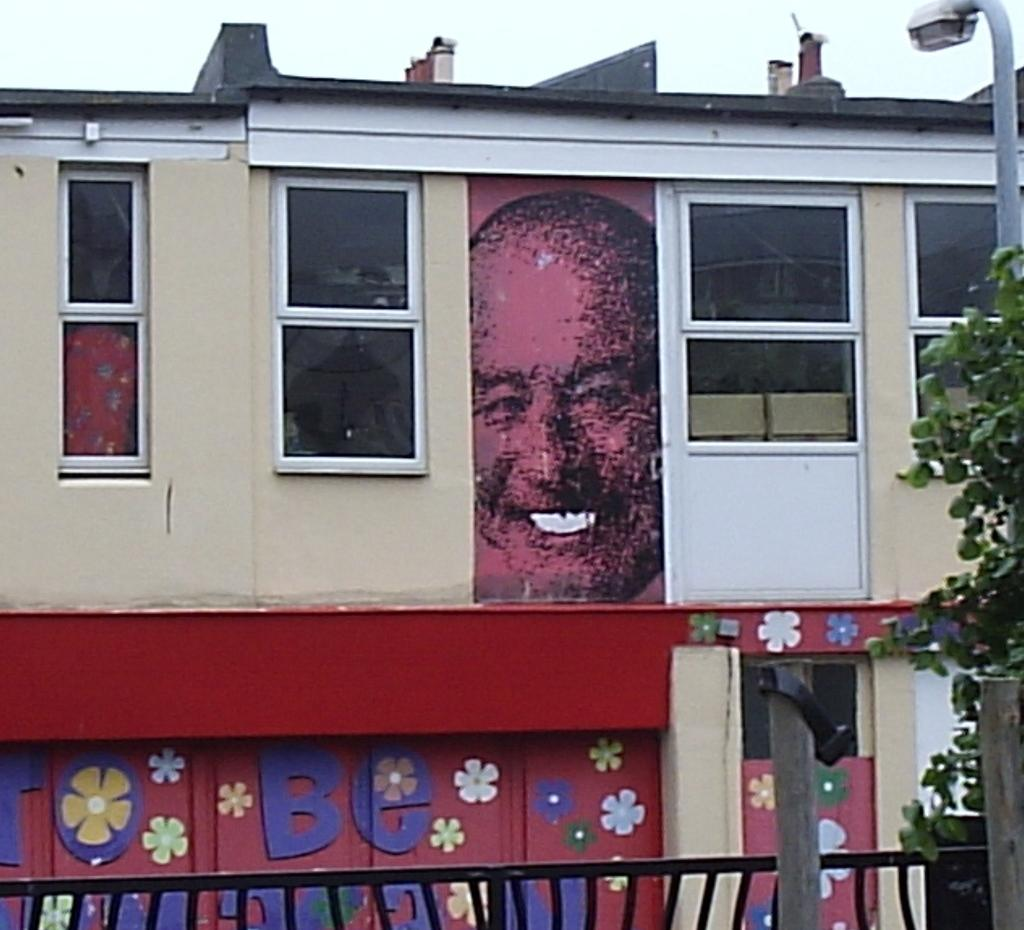What is the main subject of the picture? The main subject of the picture is a building. What can be observed about the building's appearance? The building is painted with different pictures. What is located on the right side of the picture? There is a street pole on the right side of the picture. What type of natural element is present in the picture? There is a tree in the picture. What type of texture can be seen on the volcano in the image? There is no volcano present in the image, so it is not possible to determine the texture of a volcano. What achievements has the achiever in the image accomplished? There is no achiever or any indication of achievements in the image. 